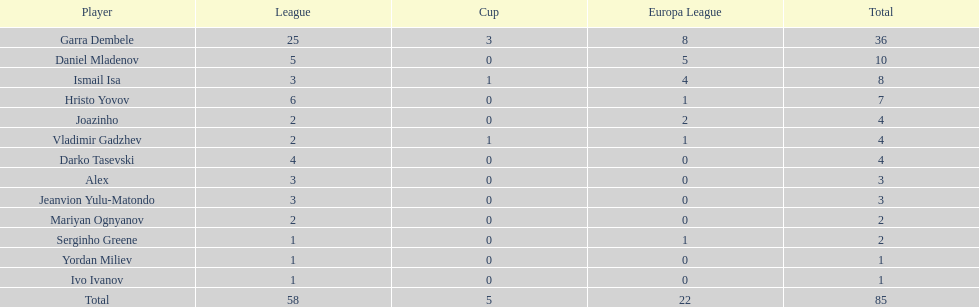What is the variation between vladimir gadzhev and yordan miliev's scores? 3. 